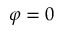Convert formula to latex. <formula><loc_0><loc_0><loc_500><loc_500>\varphi = 0</formula> 